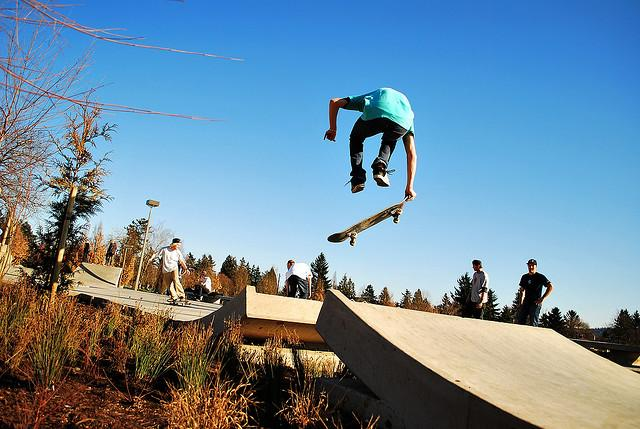Why is he grabbing the board? Please explain your reasoning. keep it. A skateboarder is holding onto the tip of a skateboard as he goes over a jump. 